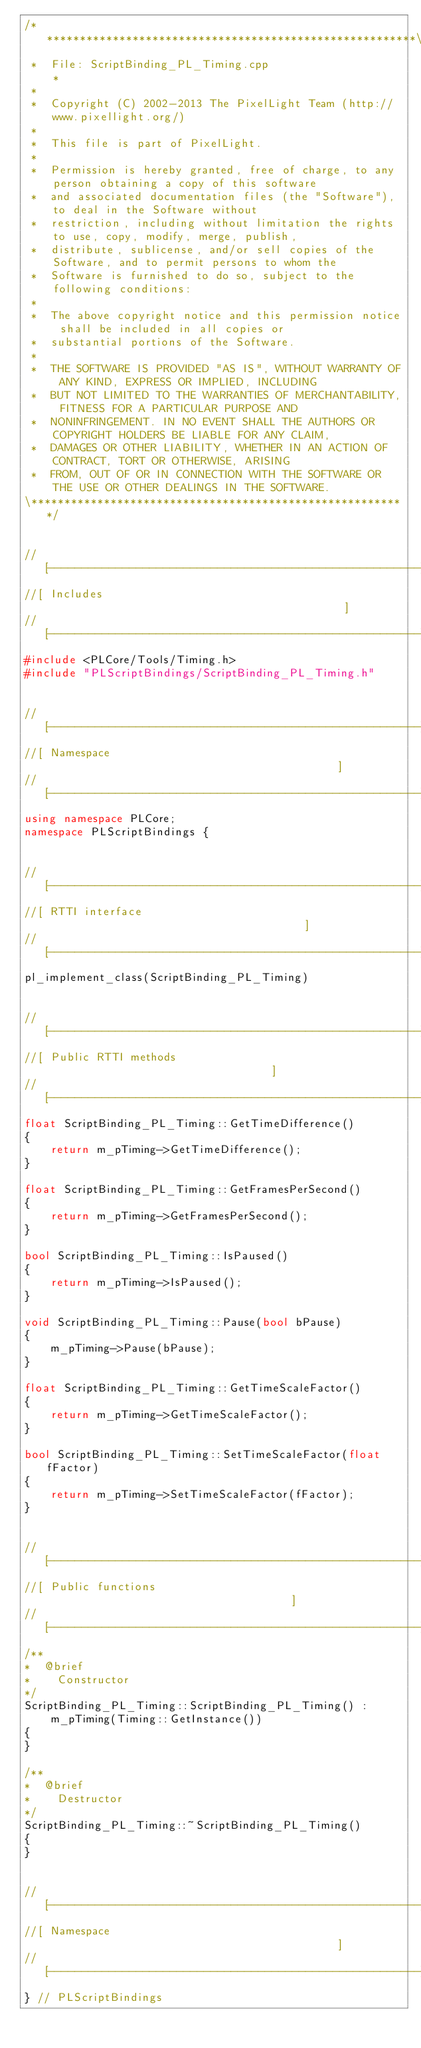Convert code to text. <code><loc_0><loc_0><loc_500><loc_500><_C++_>/*********************************************************\
 *  File: ScriptBinding_PL_Timing.cpp                    *
 *
 *  Copyright (C) 2002-2013 The PixelLight Team (http://www.pixellight.org/)
 *
 *  This file is part of PixelLight.
 *
 *  Permission is hereby granted, free of charge, to any person obtaining a copy of this software
 *  and associated documentation files (the "Software"), to deal in the Software without
 *  restriction, including without limitation the rights to use, copy, modify, merge, publish,
 *  distribute, sublicense, and/or sell copies of the Software, and to permit persons to whom the
 *  Software is furnished to do so, subject to the following conditions:
 *
 *  The above copyright notice and this permission notice shall be included in all copies or
 *  substantial portions of the Software.
 *
 *  THE SOFTWARE IS PROVIDED "AS IS", WITHOUT WARRANTY OF ANY KIND, EXPRESS OR IMPLIED, INCLUDING
 *  BUT NOT LIMITED TO THE WARRANTIES OF MERCHANTABILITY, FITNESS FOR A PARTICULAR PURPOSE AND
 *  NONINFRINGEMENT. IN NO EVENT SHALL THE AUTHORS OR COPYRIGHT HOLDERS BE LIABLE FOR ANY CLAIM,
 *  DAMAGES OR OTHER LIABILITY, WHETHER IN AN ACTION OF CONTRACT, TORT OR OTHERWISE, ARISING
 *  FROM, OUT OF OR IN CONNECTION WITH THE SOFTWARE OR THE USE OR OTHER DEALINGS IN THE SOFTWARE.
\*********************************************************/


//[-------------------------------------------------------]
//[ Includes                                              ]
//[-------------------------------------------------------]
#include <PLCore/Tools/Timing.h>
#include "PLScriptBindings/ScriptBinding_PL_Timing.h"


//[-------------------------------------------------------]
//[ Namespace                                             ]
//[-------------------------------------------------------]
using namespace PLCore;
namespace PLScriptBindings {


//[-------------------------------------------------------]
//[ RTTI interface                                        ]
//[-------------------------------------------------------]
pl_implement_class(ScriptBinding_PL_Timing)


//[-------------------------------------------------------]
//[ Public RTTI methods                                   ]
//[-------------------------------------------------------]
float ScriptBinding_PL_Timing::GetTimeDifference()
{
	return m_pTiming->GetTimeDifference();
}

float ScriptBinding_PL_Timing::GetFramesPerSecond()
{
	return m_pTiming->GetFramesPerSecond();
}

bool ScriptBinding_PL_Timing::IsPaused()
{
	return m_pTiming->IsPaused();
}

void ScriptBinding_PL_Timing::Pause(bool bPause)
{
	m_pTiming->Pause(bPause);
}

float ScriptBinding_PL_Timing::GetTimeScaleFactor()
{
	return m_pTiming->GetTimeScaleFactor();
}

bool ScriptBinding_PL_Timing::SetTimeScaleFactor(float fFactor)
{
	return m_pTiming->SetTimeScaleFactor(fFactor);
}


//[-------------------------------------------------------]
//[ Public functions                                      ]
//[-------------------------------------------------------]
/**
*  @brief
*    Constructor
*/
ScriptBinding_PL_Timing::ScriptBinding_PL_Timing() :
	m_pTiming(Timing::GetInstance())
{
}

/**
*  @brief
*    Destructor
*/
ScriptBinding_PL_Timing::~ScriptBinding_PL_Timing()
{
}


//[-------------------------------------------------------]
//[ Namespace                                             ]
//[-------------------------------------------------------]
} // PLScriptBindings
</code> 